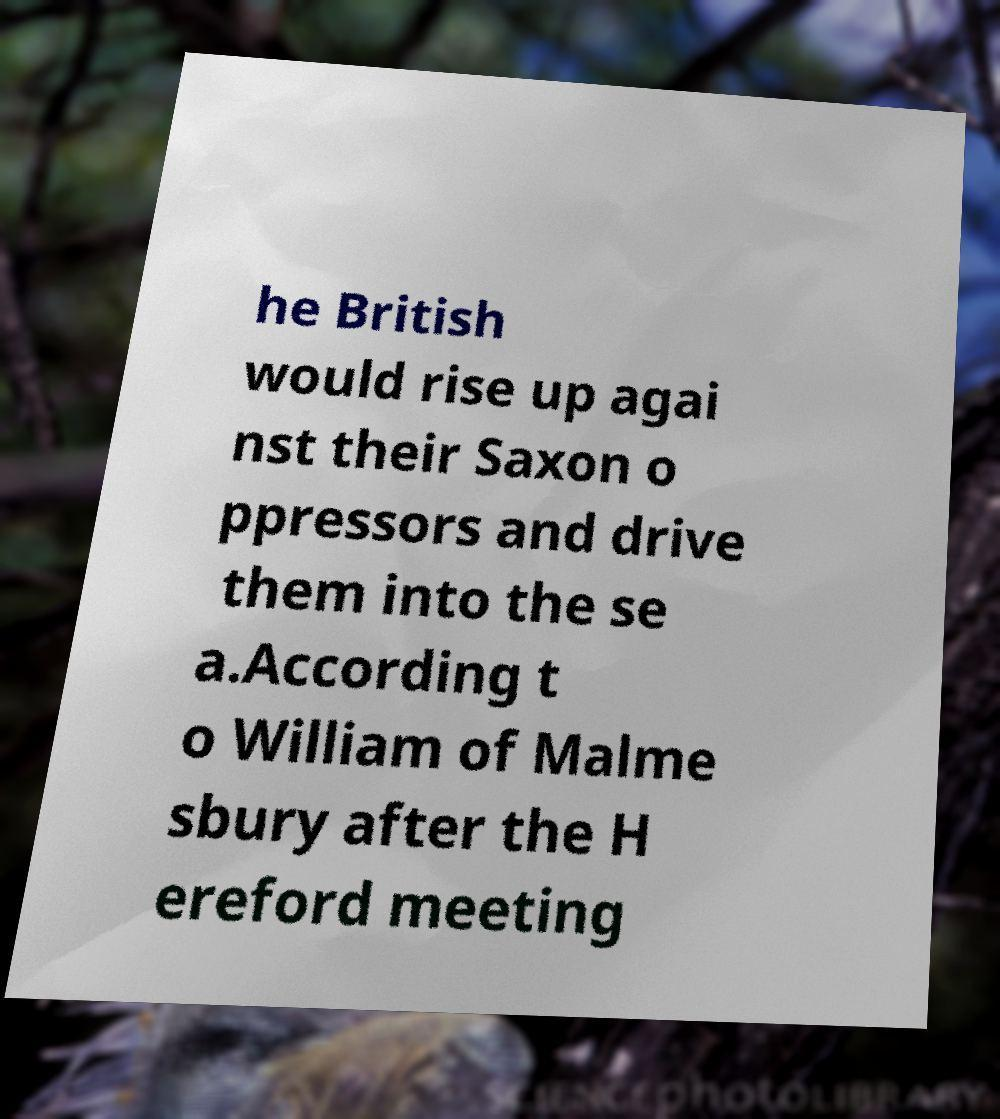For documentation purposes, I need the text within this image transcribed. Could you provide that? he British would rise up agai nst their Saxon o ppressors and drive them into the se a.According t o William of Malme sbury after the H ereford meeting 